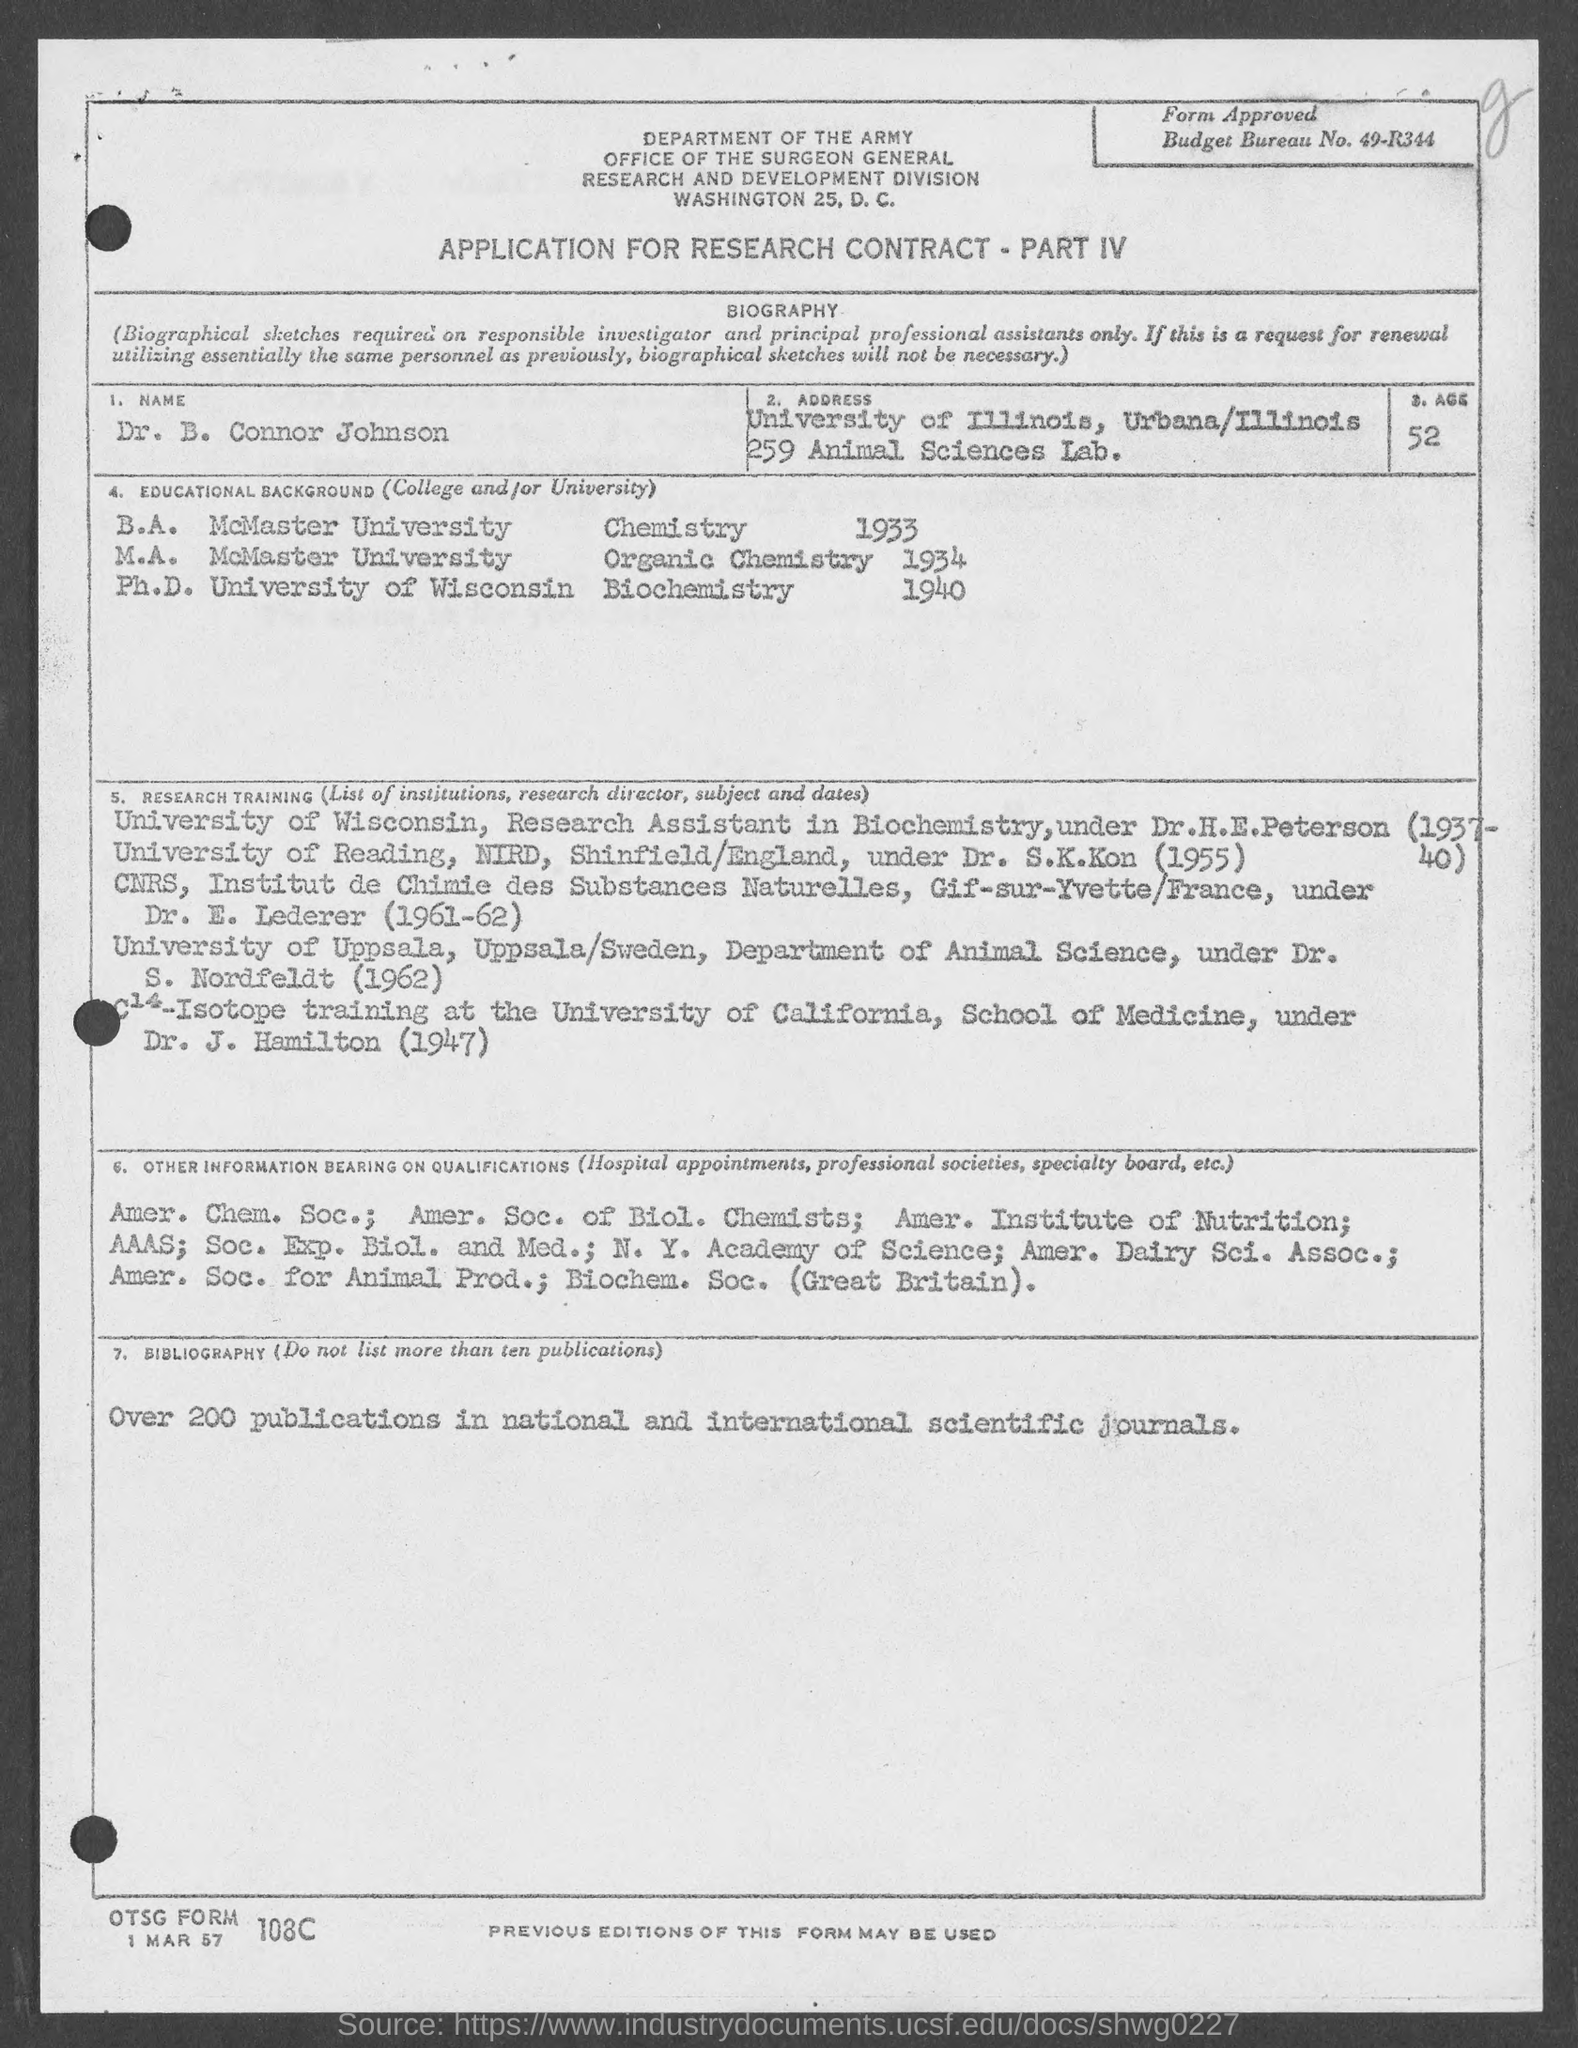What is the Budget Bureau No. given in the application?
Offer a terse response. 49-R344. What is the name given in the application?
Your answer should be very brief. Dr. B. Connor Johnson. What is the age of Dr. B. Connor Johnson as per the application?
Provide a succinct answer. 52. When did Dr. B. Connor Johnson completed M.A. degree in Organic Chemistry?
Your response must be concise. 1934. In which University, Dr. B. Connor Johnson completed his Ph.D. in Biochemistry?
Your response must be concise. University of Wisconsin. When did Dr. B. Connor Johnson completed B.A. degree in Chemistry?
Give a very brief answer. 1933. During which period, Dr. B. Connor Johnson worked as Research Assistant in Biochemistry under Dr.H.E.Peterson?
Your answer should be compact. (1937-40). 